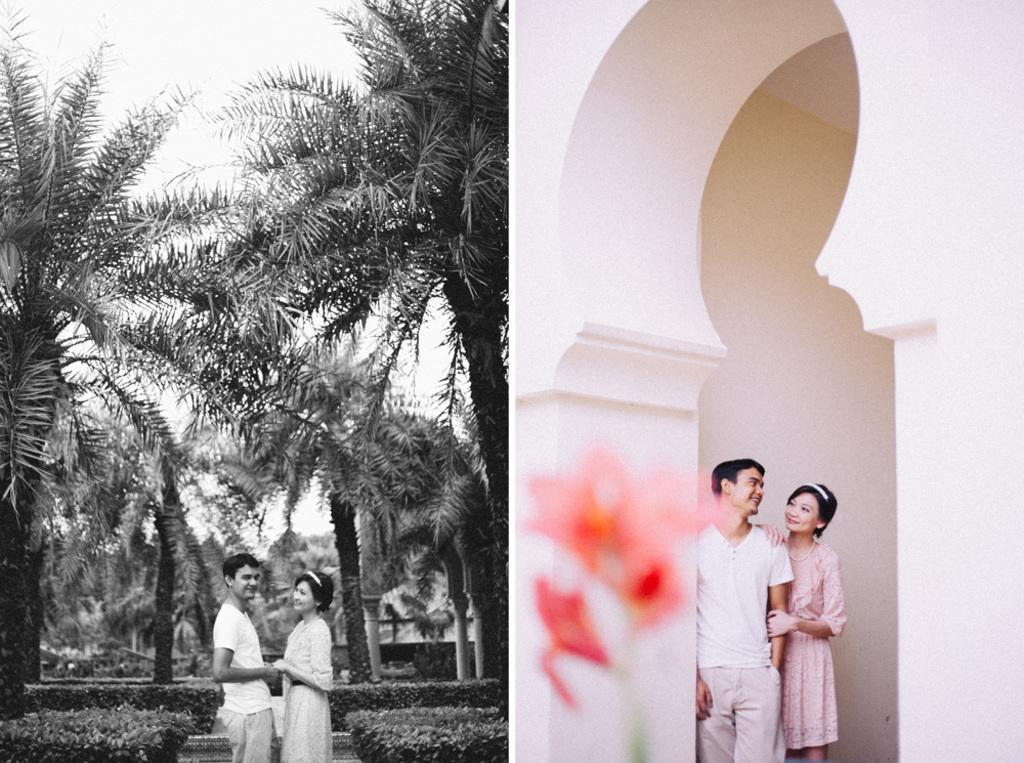Can you describe this image briefly? This is the collage of two images. The first image is black and white where we can see plants, trees, sky, a man and a woman. In the second image, we can see a man, woman, wall and flowers. 